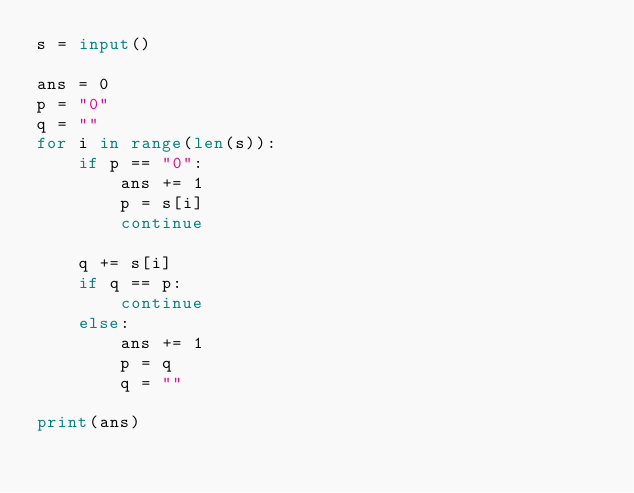<code> <loc_0><loc_0><loc_500><loc_500><_Python_>s = input()

ans = 0
p = "0"
q = ""
for i in range(len(s)):
    if p == "0":
        ans += 1
        p = s[i]
        continue

    q += s[i]
    if q == p:
        continue
    else:
        ans += 1
        p = q
        q = ""
        
print(ans)
        
    
        
        

                                        




    




        


    







        

</code> 